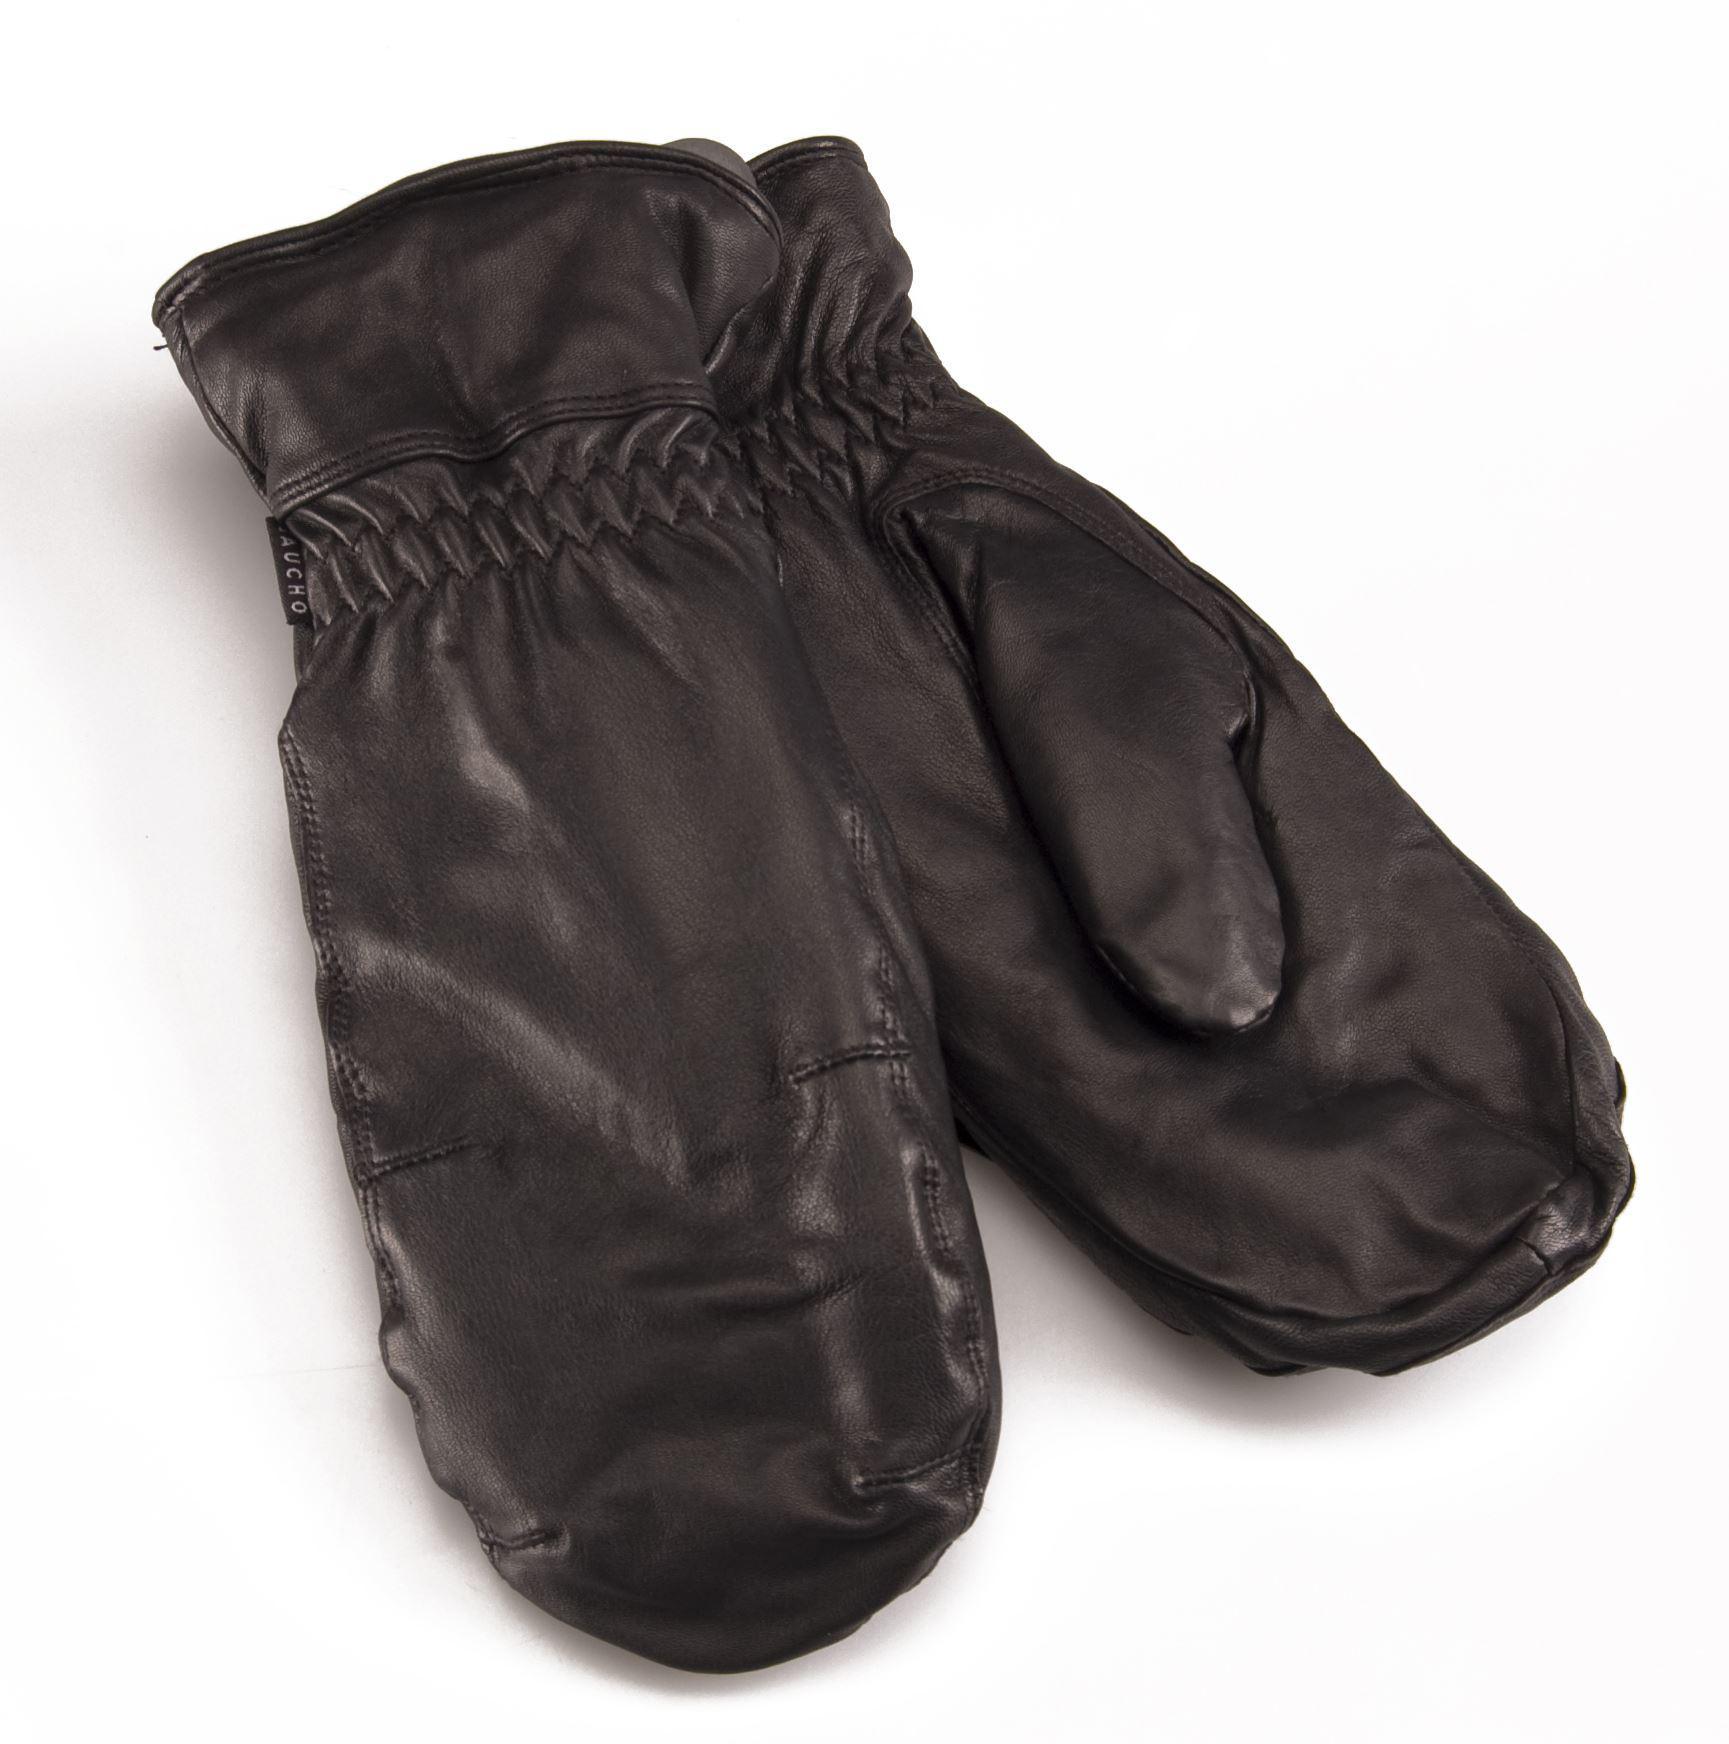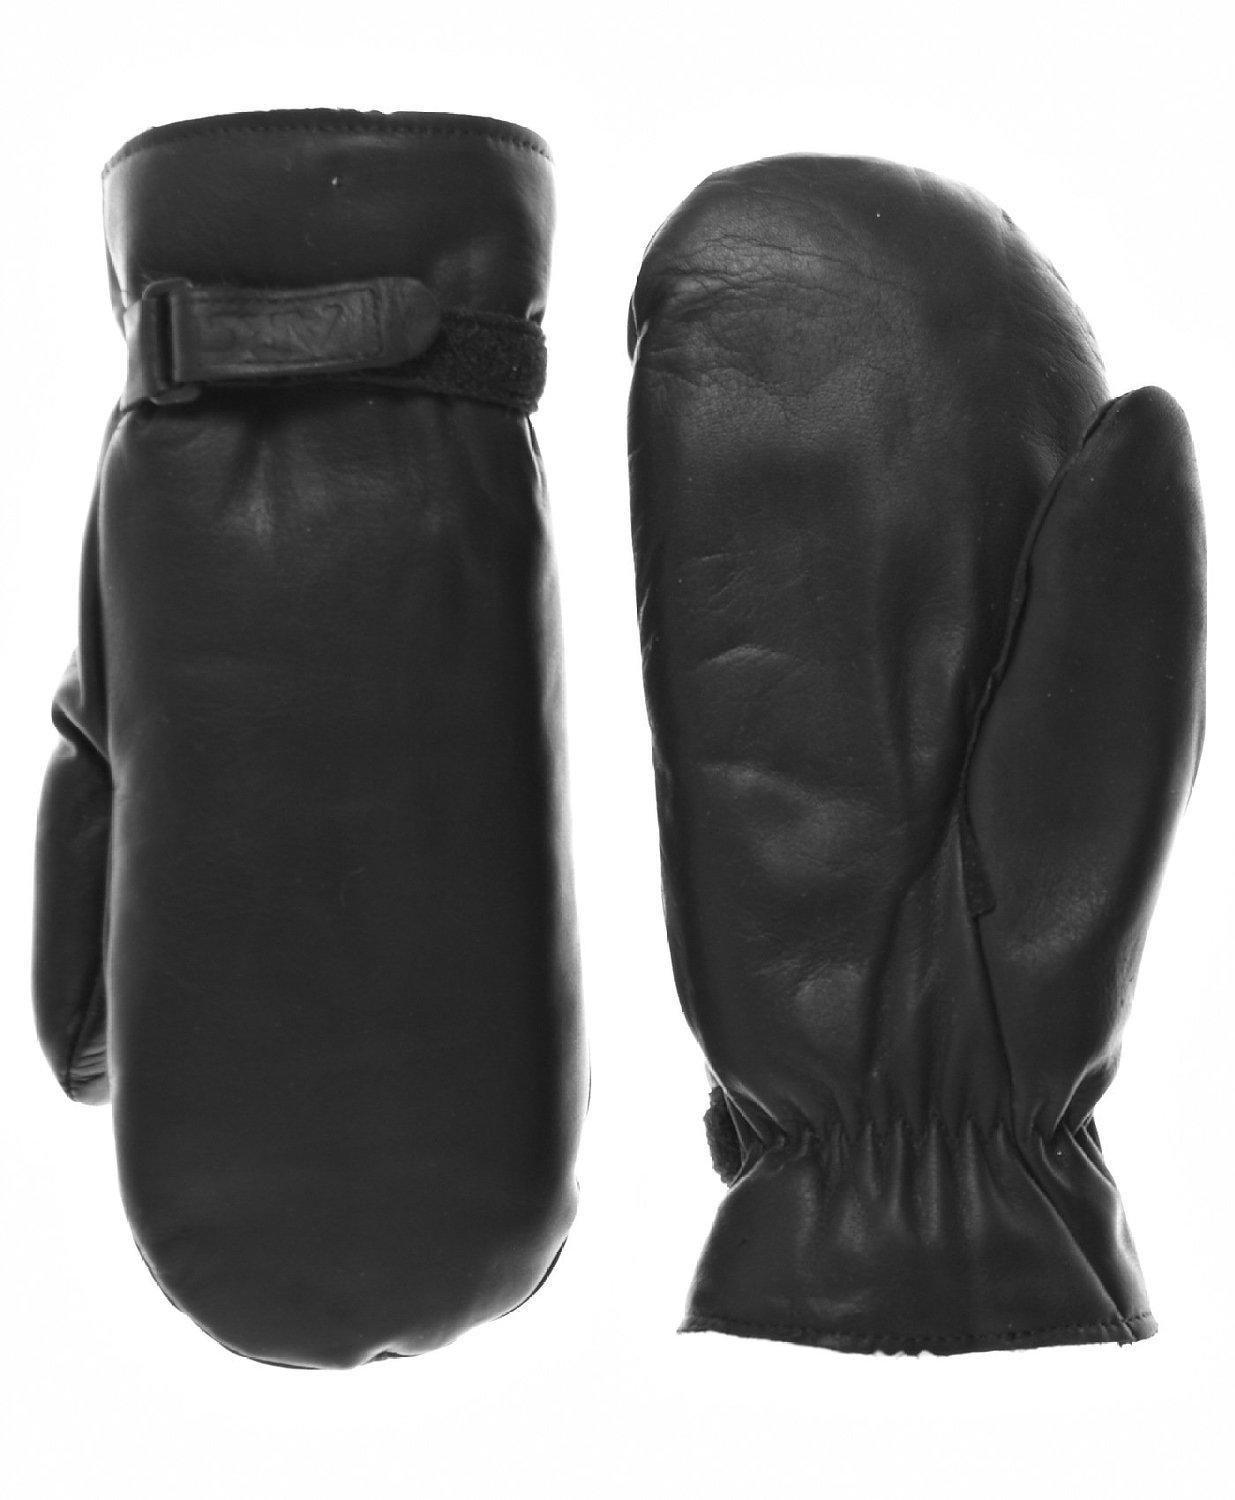The first image is the image on the left, the second image is the image on the right. Considering the images on both sides, is "Each image shows exactly two mittens, and each pair of mittens is displayed with the two mittens overlapping." valid? Answer yes or no. No. The first image is the image on the left, the second image is the image on the right. Evaluate the accuracy of this statement regarding the images: "One pair of dark brown leather mittens has elastic gathering around the wrists, and is displayed angled with one mitten facing each way.". Is it true? Answer yes or no. Yes. 